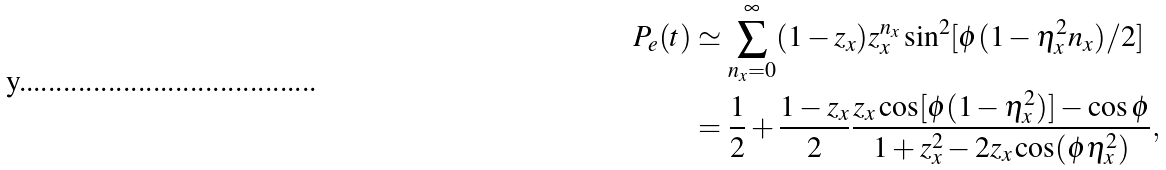<formula> <loc_0><loc_0><loc_500><loc_500>P _ { e } ( t ) & \simeq \sum _ { n _ { x } = 0 } ^ { \infty } ( 1 - z _ { x } ) z _ { x } ^ { n _ { x } } \sin ^ { 2 } [ \phi ( 1 - \eta _ { x } ^ { 2 } n _ { x } ) / 2 ] \\ & = \frac { 1 } { 2 } + \frac { 1 - z _ { x } } { 2 } \frac { z _ { x } \cos [ \phi ( 1 - \eta _ { x } ^ { 2 } ) ] - \cos \phi } { 1 + z _ { x } ^ { 2 } - 2 z _ { x } \cos ( \phi \eta _ { x } ^ { 2 } ) } ,</formula> 